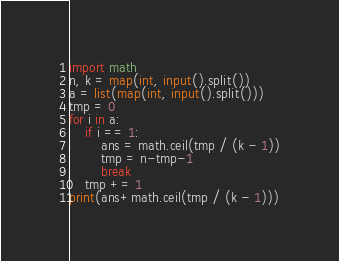<code> <loc_0><loc_0><loc_500><loc_500><_Python_>import math
n, k = map(int, input().split())
a = list(map(int, input().split()))
tmp = 0
for i in a:
    if i == 1:
        ans = math.ceil(tmp / (k - 1))
        tmp = n-tmp-1
        break
    tmp += 1
print(ans+math.ceil(tmp / (k - 1)))</code> 